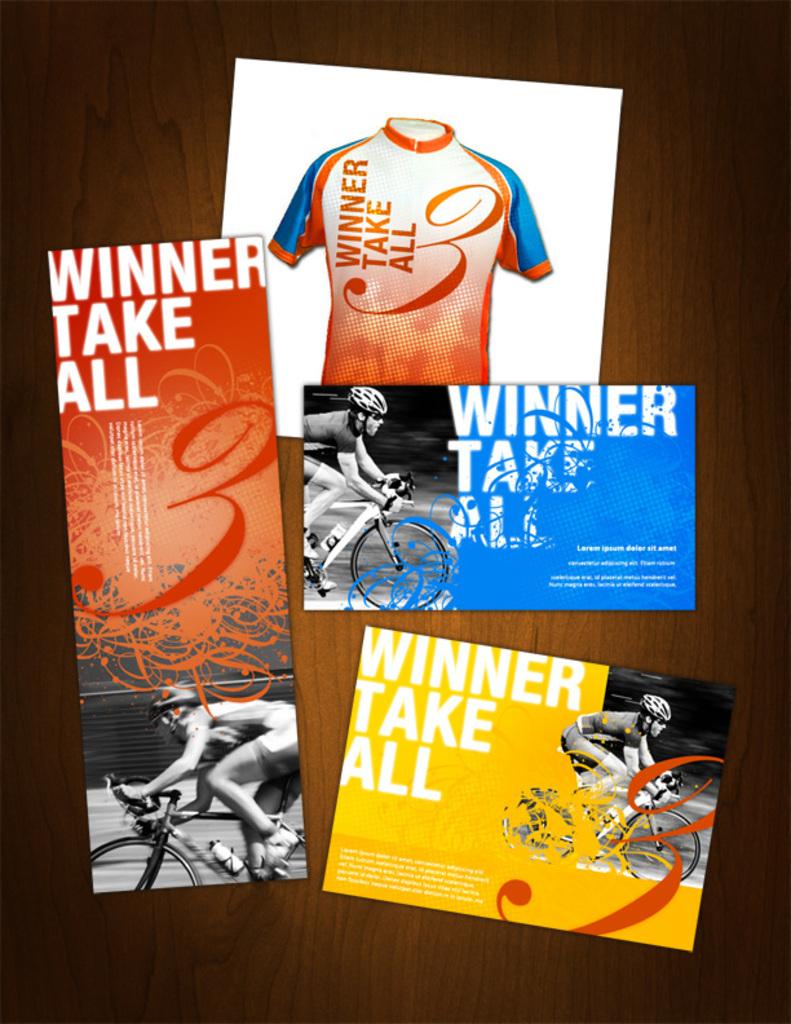What does the winner take?
Your response must be concise. All. 